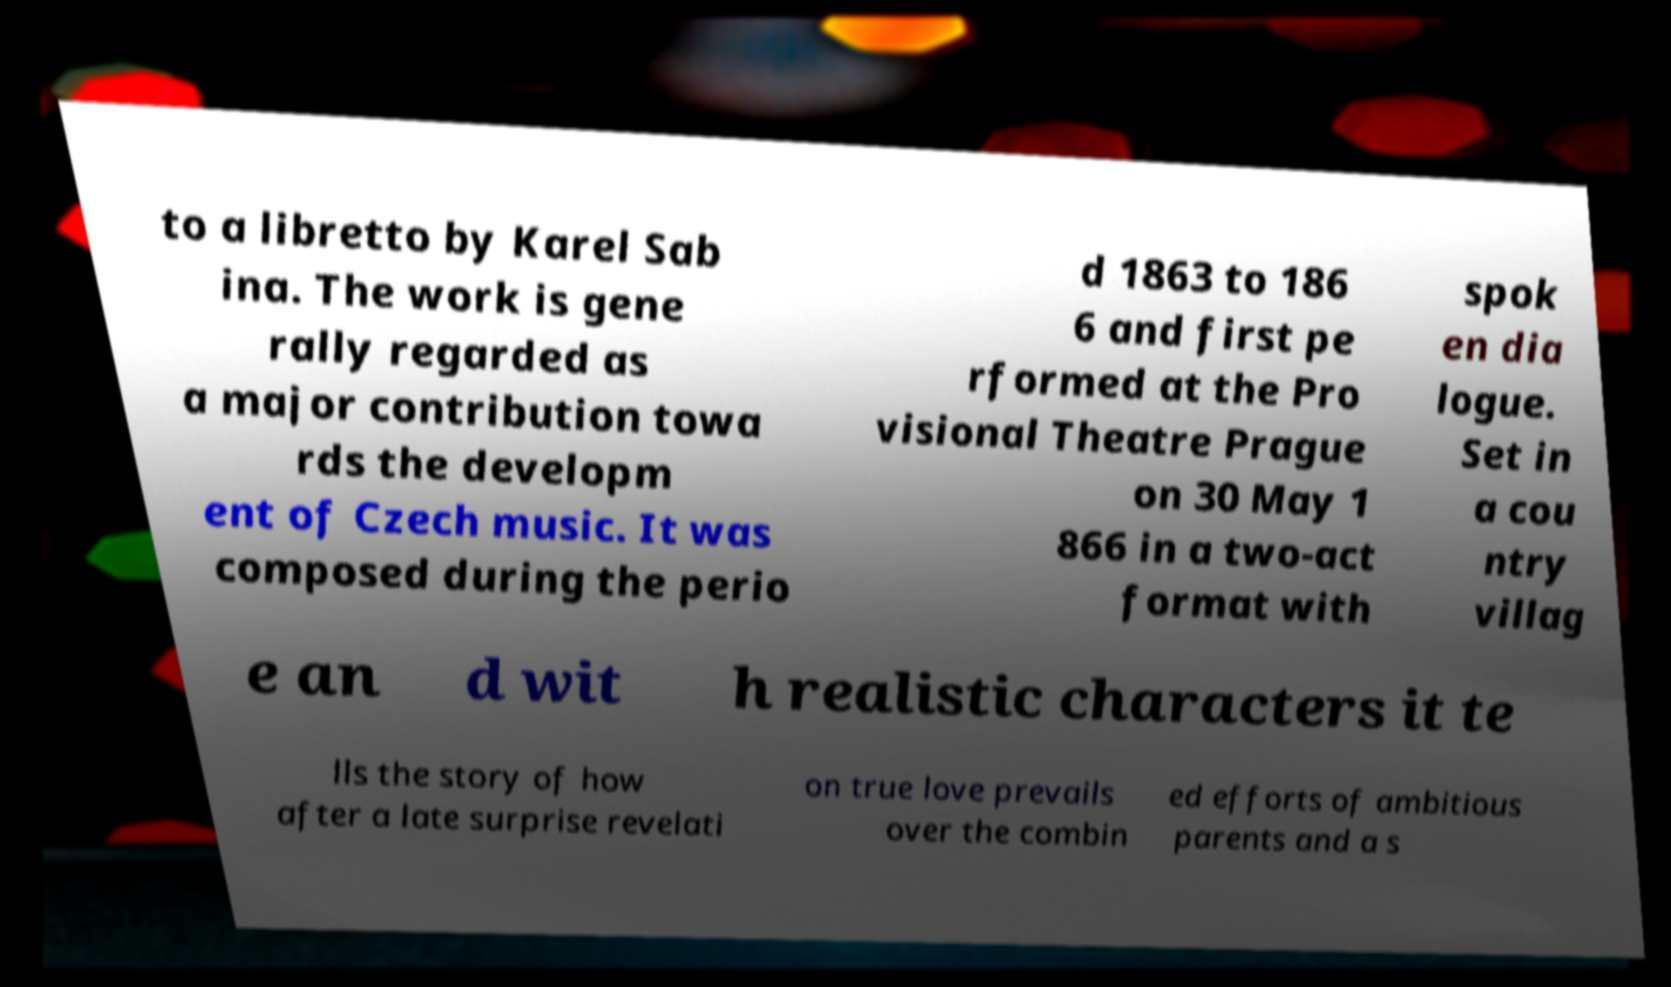Please read and relay the text visible in this image. What does it say? to a libretto by Karel Sab ina. The work is gene rally regarded as a major contribution towa rds the developm ent of Czech music. It was composed during the perio d 1863 to 186 6 and first pe rformed at the Pro visional Theatre Prague on 30 May 1 866 in a two-act format with spok en dia logue. Set in a cou ntry villag e an d wit h realistic characters it te lls the story of how after a late surprise revelati on true love prevails over the combin ed efforts of ambitious parents and a s 